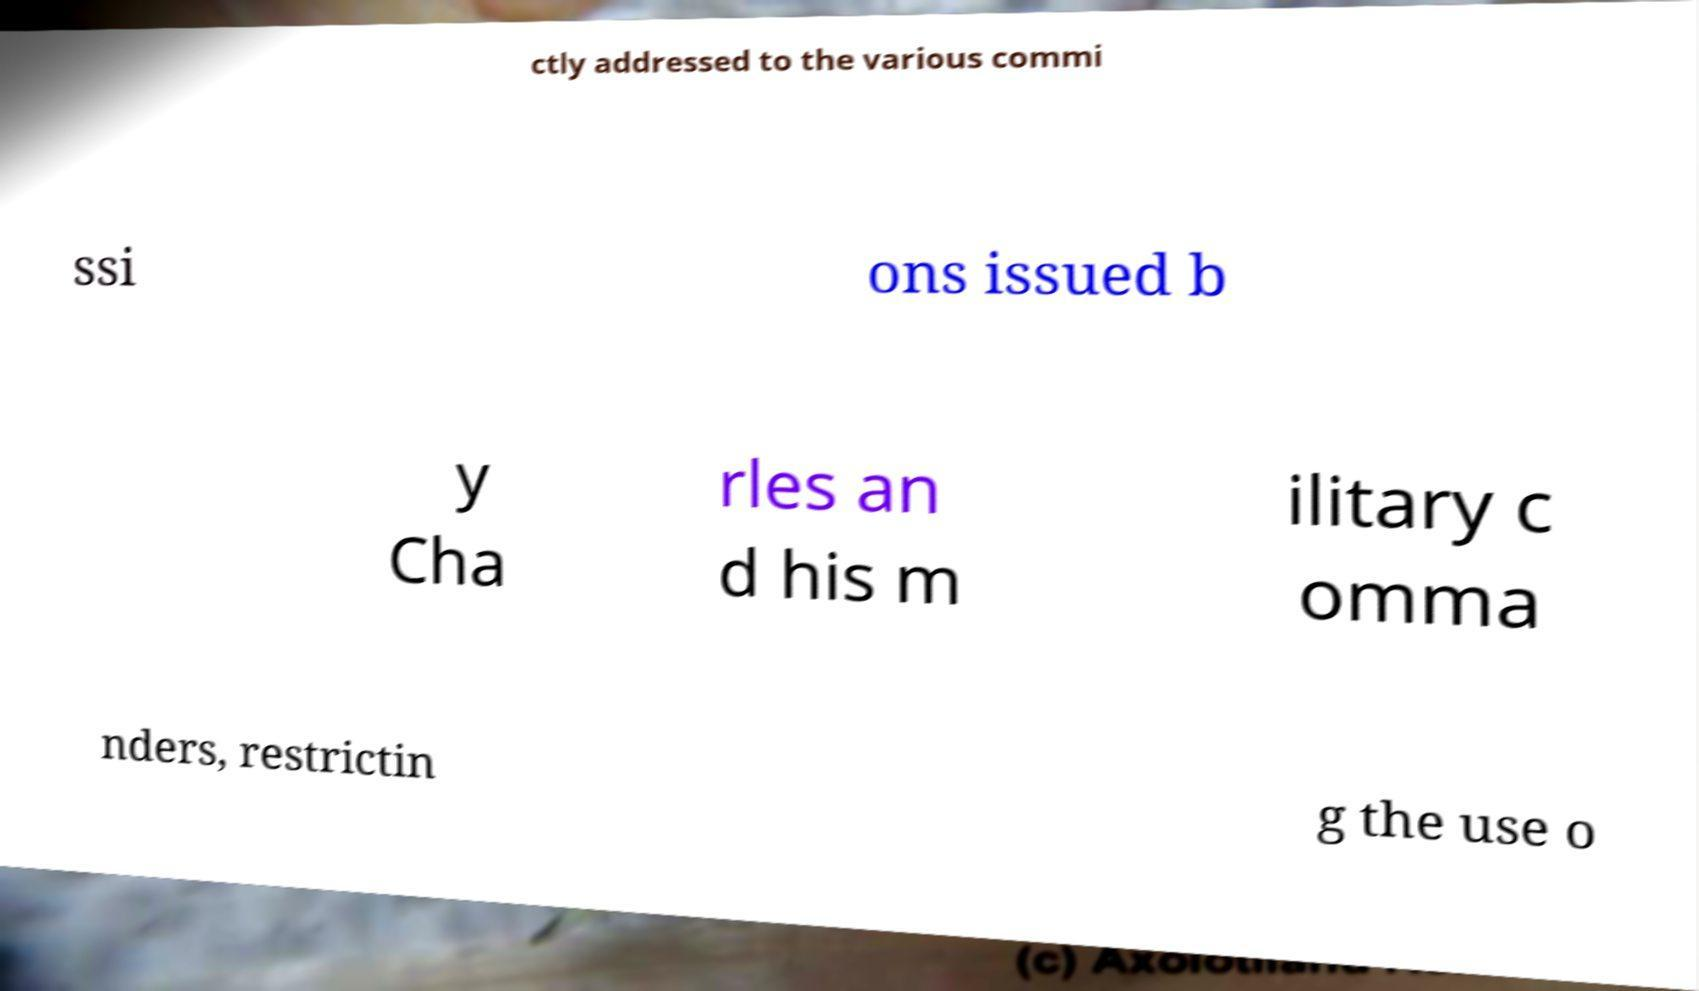I need the written content from this picture converted into text. Can you do that? ctly addressed to the various commi ssi ons issued b y Cha rles an d his m ilitary c omma nders, restrictin g the use o 